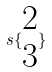Convert formula to latex. <formula><loc_0><loc_0><loc_500><loc_500>s \{ \begin{matrix} 2 \\ 3 \end{matrix} \}</formula> 